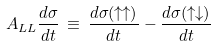<formula> <loc_0><loc_0><loc_500><loc_500>A _ { L L } \frac { d \sigma } { d t } \, \equiv \, \frac { d \sigma ( \uparrow \uparrow ) } { d t } - \frac { d \sigma ( \uparrow \downarrow ) } { d t } \,</formula> 